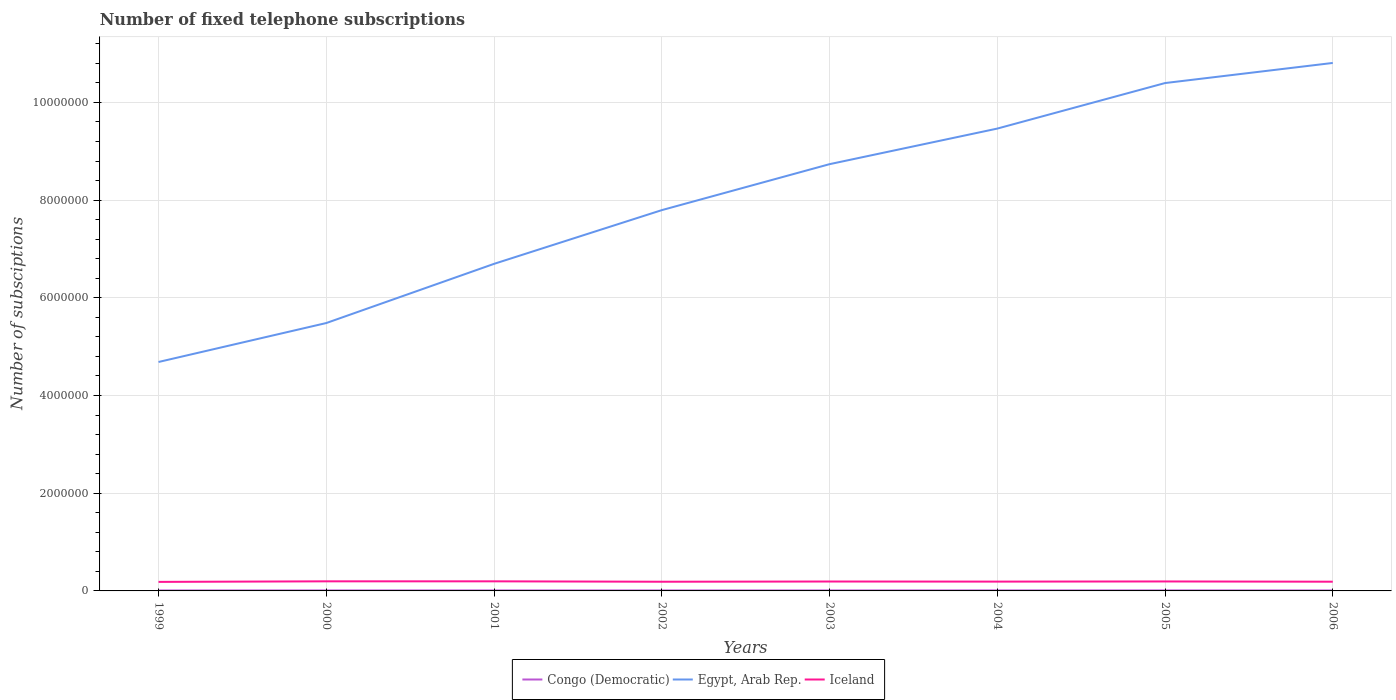How many different coloured lines are there?
Make the answer very short. 3. Does the line corresponding to Egypt, Arab Rep. intersect with the line corresponding to Iceland?
Offer a very short reply. No. Is the number of lines equal to the number of legend labels?
Make the answer very short. Yes. Across all years, what is the maximum number of fixed telephone subscriptions in Egypt, Arab Rep.?
Keep it short and to the point. 4.69e+06. In which year was the number of fixed telephone subscriptions in Egypt, Arab Rep. maximum?
Offer a terse response. 1999. What is the total number of fixed telephone subscriptions in Egypt, Arab Rep. in the graph?
Make the answer very short. -4.78e+06. What is the difference between the highest and the second highest number of fixed telephone subscriptions in Egypt, Arab Rep.?
Your response must be concise. 6.12e+06. What is the difference between the highest and the lowest number of fixed telephone subscriptions in Egypt, Arab Rep.?
Make the answer very short. 4. Is the number of fixed telephone subscriptions in Egypt, Arab Rep. strictly greater than the number of fixed telephone subscriptions in Iceland over the years?
Provide a succinct answer. No. How many lines are there?
Ensure brevity in your answer.  3. How many legend labels are there?
Keep it short and to the point. 3. How are the legend labels stacked?
Make the answer very short. Horizontal. What is the title of the graph?
Keep it short and to the point. Number of fixed telephone subscriptions. Does "Finland" appear as one of the legend labels in the graph?
Your answer should be compact. No. What is the label or title of the X-axis?
Provide a short and direct response. Years. What is the label or title of the Y-axis?
Keep it short and to the point. Number of subsciptions. What is the Number of subsciptions in Congo (Democratic) in 1999?
Your response must be concise. 9550. What is the Number of subsciptions of Egypt, Arab Rep. in 1999?
Offer a very short reply. 4.69e+06. What is the Number of subsciptions in Iceland in 1999?
Keep it short and to the point. 1.85e+05. What is the Number of subsciptions of Congo (Democratic) in 2000?
Your response must be concise. 9810. What is the Number of subsciptions in Egypt, Arab Rep. in 2000?
Ensure brevity in your answer.  5.48e+06. What is the Number of subsciptions in Iceland in 2000?
Make the answer very short. 1.96e+05. What is the Number of subsciptions of Congo (Democratic) in 2001?
Offer a very short reply. 9980. What is the Number of subsciptions of Egypt, Arab Rep. in 2001?
Your answer should be compact. 6.69e+06. What is the Number of subsciptions of Iceland in 2001?
Your response must be concise. 1.97e+05. What is the Number of subsciptions in Egypt, Arab Rep. in 2002?
Offer a very short reply. 7.79e+06. What is the Number of subsciptions of Iceland in 2002?
Ensure brevity in your answer.  1.88e+05. What is the Number of subsciptions in Congo (Democratic) in 2003?
Give a very brief answer. 9733. What is the Number of subsciptions of Egypt, Arab Rep. in 2003?
Give a very brief answer. 8.74e+06. What is the Number of subsciptions of Iceland in 2003?
Your answer should be compact. 1.93e+05. What is the Number of subsciptions of Congo (Democratic) in 2004?
Ensure brevity in your answer.  1.05e+04. What is the Number of subsciptions of Egypt, Arab Rep. in 2004?
Make the answer very short. 9.46e+06. What is the Number of subsciptions in Iceland in 2004?
Make the answer very short. 1.90e+05. What is the Number of subsciptions of Congo (Democratic) in 2005?
Give a very brief answer. 1.06e+04. What is the Number of subsciptions in Egypt, Arab Rep. in 2005?
Give a very brief answer. 1.04e+07. What is the Number of subsciptions in Iceland in 2005?
Make the answer very short. 1.94e+05. What is the Number of subsciptions of Congo (Democratic) in 2006?
Give a very brief answer. 9700. What is the Number of subsciptions of Egypt, Arab Rep. in 2006?
Keep it short and to the point. 1.08e+07. What is the Number of subsciptions in Iceland in 2006?
Your answer should be very brief. 1.89e+05. Across all years, what is the maximum Number of subsciptions of Congo (Democratic)?
Ensure brevity in your answer.  1.06e+04. Across all years, what is the maximum Number of subsciptions of Egypt, Arab Rep.?
Your answer should be compact. 1.08e+07. Across all years, what is the maximum Number of subsciptions of Iceland?
Provide a short and direct response. 1.97e+05. Across all years, what is the minimum Number of subsciptions in Congo (Democratic)?
Your response must be concise. 9550. Across all years, what is the minimum Number of subsciptions of Egypt, Arab Rep.?
Ensure brevity in your answer.  4.69e+06. Across all years, what is the minimum Number of subsciptions of Iceland?
Provide a succinct answer. 1.85e+05. What is the total Number of subsciptions of Congo (Democratic) in the graph?
Ensure brevity in your answer.  7.99e+04. What is the total Number of subsciptions of Egypt, Arab Rep. in the graph?
Your response must be concise. 6.41e+07. What is the total Number of subsciptions in Iceland in the graph?
Make the answer very short. 1.53e+06. What is the difference between the Number of subsciptions of Congo (Democratic) in 1999 and that in 2000?
Your answer should be very brief. -260. What is the difference between the Number of subsciptions of Egypt, Arab Rep. in 1999 and that in 2000?
Make the answer very short. -7.97e+05. What is the difference between the Number of subsciptions of Iceland in 1999 and that in 2000?
Keep it short and to the point. -1.14e+04. What is the difference between the Number of subsciptions in Congo (Democratic) in 1999 and that in 2001?
Make the answer very short. -430. What is the difference between the Number of subsciptions of Egypt, Arab Rep. in 1999 and that in 2001?
Ensure brevity in your answer.  -2.01e+06. What is the difference between the Number of subsciptions in Iceland in 1999 and that in 2001?
Keep it short and to the point. -1.16e+04. What is the difference between the Number of subsciptions in Congo (Democratic) in 1999 and that in 2002?
Make the answer very short. -450. What is the difference between the Number of subsciptions of Egypt, Arab Rep. in 1999 and that in 2002?
Offer a terse response. -3.11e+06. What is the difference between the Number of subsciptions of Iceland in 1999 and that in 2002?
Offer a terse response. -3026. What is the difference between the Number of subsciptions in Congo (Democratic) in 1999 and that in 2003?
Your response must be concise. -183. What is the difference between the Number of subsciptions in Egypt, Arab Rep. in 1999 and that in 2003?
Your answer should be very brief. -4.05e+06. What is the difference between the Number of subsciptions in Iceland in 1999 and that in 2003?
Your response must be concise. -7579. What is the difference between the Number of subsciptions in Congo (Democratic) in 1999 and that in 2004?
Your answer should be compact. -974. What is the difference between the Number of subsciptions of Egypt, Arab Rep. in 1999 and that in 2004?
Keep it short and to the point. -4.78e+06. What is the difference between the Number of subsciptions in Iceland in 1999 and that in 2004?
Your response must be concise. -5505. What is the difference between the Number of subsciptions of Congo (Democratic) in 1999 and that in 2005?
Provide a succinct answer. -1029. What is the difference between the Number of subsciptions in Egypt, Arab Rep. in 1999 and that in 2005?
Provide a succinct answer. -5.71e+06. What is the difference between the Number of subsciptions of Iceland in 1999 and that in 2005?
Your response must be concise. -8879. What is the difference between the Number of subsciptions in Congo (Democratic) in 1999 and that in 2006?
Ensure brevity in your answer.  -150. What is the difference between the Number of subsciptions of Egypt, Arab Rep. in 1999 and that in 2006?
Offer a terse response. -6.12e+06. What is the difference between the Number of subsciptions in Iceland in 1999 and that in 2006?
Offer a very short reply. -3602. What is the difference between the Number of subsciptions of Congo (Democratic) in 2000 and that in 2001?
Offer a terse response. -170. What is the difference between the Number of subsciptions in Egypt, Arab Rep. in 2000 and that in 2001?
Give a very brief answer. -1.21e+06. What is the difference between the Number of subsciptions of Iceland in 2000 and that in 2001?
Provide a succinct answer. -192. What is the difference between the Number of subsciptions in Congo (Democratic) in 2000 and that in 2002?
Provide a short and direct response. -190. What is the difference between the Number of subsciptions of Egypt, Arab Rep. in 2000 and that in 2002?
Keep it short and to the point. -2.31e+06. What is the difference between the Number of subsciptions of Iceland in 2000 and that in 2002?
Offer a very short reply. 8337. What is the difference between the Number of subsciptions in Congo (Democratic) in 2000 and that in 2003?
Your response must be concise. 77. What is the difference between the Number of subsciptions of Egypt, Arab Rep. in 2000 and that in 2003?
Provide a short and direct response. -3.25e+06. What is the difference between the Number of subsciptions of Iceland in 2000 and that in 2003?
Offer a very short reply. 3784. What is the difference between the Number of subsciptions of Congo (Democratic) in 2000 and that in 2004?
Your answer should be very brief. -714. What is the difference between the Number of subsciptions in Egypt, Arab Rep. in 2000 and that in 2004?
Give a very brief answer. -3.98e+06. What is the difference between the Number of subsciptions of Iceland in 2000 and that in 2004?
Your answer should be compact. 5858. What is the difference between the Number of subsciptions of Congo (Democratic) in 2000 and that in 2005?
Provide a succinct answer. -769. What is the difference between the Number of subsciptions of Egypt, Arab Rep. in 2000 and that in 2005?
Offer a terse response. -4.91e+06. What is the difference between the Number of subsciptions of Iceland in 2000 and that in 2005?
Keep it short and to the point. 2484. What is the difference between the Number of subsciptions in Congo (Democratic) in 2000 and that in 2006?
Offer a very short reply. 110. What is the difference between the Number of subsciptions in Egypt, Arab Rep. in 2000 and that in 2006?
Offer a very short reply. -5.32e+06. What is the difference between the Number of subsciptions in Iceland in 2000 and that in 2006?
Provide a succinct answer. 7761. What is the difference between the Number of subsciptions in Congo (Democratic) in 2001 and that in 2002?
Your answer should be very brief. -20. What is the difference between the Number of subsciptions of Egypt, Arab Rep. in 2001 and that in 2002?
Make the answer very short. -1.10e+06. What is the difference between the Number of subsciptions of Iceland in 2001 and that in 2002?
Your answer should be compact. 8529. What is the difference between the Number of subsciptions of Congo (Democratic) in 2001 and that in 2003?
Your answer should be compact. 247. What is the difference between the Number of subsciptions of Egypt, Arab Rep. in 2001 and that in 2003?
Your answer should be compact. -2.04e+06. What is the difference between the Number of subsciptions of Iceland in 2001 and that in 2003?
Offer a terse response. 3976. What is the difference between the Number of subsciptions of Congo (Democratic) in 2001 and that in 2004?
Provide a succinct answer. -544. What is the difference between the Number of subsciptions of Egypt, Arab Rep. in 2001 and that in 2004?
Give a very brief answer. -2.77e+06. What is the difference between the Number of subsciptions of Iceland in 2001 and that in 2004?
Provide a succinct answer. 6050. What is the difference between the Number of subsciptions in Congo (Democratic) in 2001 and that in 2005?
Your answer should be compact. -599. What is the difference between the Number of subsciptions in Egypt, Arab Rep. in 2001 and that in 2005?
Provide a succinct answer. -3.70e+06. What is the difference between the Number of subsciptions in Iceland in 2001 and that in 2005?
Your answer should be very brief. 2676. What is the difference between the Number of subsciptions in Congo (Democratic) in 2001 and that in 2006?
Keep it short and to the point. 280. What is the difference between the Number of subsciptions in Egypt, Arab Rep. in 2001 and that in 2006?
Your answer should be very brief. -4.11e+06. What is the difference between the Number of subsciptions in Iceland in 2001 and that in 2006?
Keep it short and to the point. 7953. What is the difference between the Number of subsciptions in Congo (Democratic) in 2002 and that in 2003?
Give a very brief answer. 267. What is the difference between the Number of subsciptions in Egypt, Arab Rep. in 2002 and that in 2003?
Make the answer very short. -9.41e+05. What is the difference between the Number of subsciptions of Iceland in 2002 and that in 2003?
Ensure brevity in your answer.  -4553. What is the difference between the Number of subsciptions in Congo (Democratic) in 2002 and that in 2004?
Provide a short and direct response. -524. What is the difference between the Number of subsciptions of Egypt, Arab Rep. in 2002 and that in 2004?
Offer a very short reply. -1.67e+06. What is the difference between the Number of subsciptions of Iceland in 2002 and that in 2004?
Provide a succinct answer. -2479. What is the difference between the Number of subsciptions of Congo (Democratic) in 2002 and that in 2005?
Your answer should be compact. -579. What is the difference between the Number of subsciptions in Egypt, Arab Rep. in 2002 and that in 2005?
Provide a succinct answer. -2.60e+06. What is the difference between the Number of subsciptions of Iceland in 2002 and that in 2005?
Your answer should be compact. -5853. What is the difference between the Number of subsciptions in Congo (Democratic) in 2002 and that in 2006?
Ensure brevity in your answer.  300. What is the difference between the Number of subsciptions of Egypt, Arab Rep. in 2002 and that in 2006?
Your response must be concise. -3.01e+06. What is the difference between the Number of subsciptions in Iceland in 2002 and that in 2006?
Make the answer very short. -576. What is the difference between the Number of subsciptions of Congo (Democratic) in 2003 and that in 2004?
Keep it short and to the point. -791. What is the difference between the Number of subsciptions of Egypt, Arab Rep. in 2003 and that in 2004?
Your answer should be very brief. -7.28e+05. What is the difference between the Number of subsciptions in Iceland in 2003 and that in 2004?
Your answer should be very brief. 2074. What is the difference between the Number of subsciptions of Congo (Democratic) in 2003 and that in 2005?
Offer a very short reply. -846. What is the difference between the Number of subsciptions of Egypt, Arab Rep. in 2003 and that in 2005?
Offer a very short reply. -1.66e+06. What is the difference between the Number of subsciptions of Iceland in 2003 and that in 2005?
Offer a very short reply. -1300. What is the difference between the Number of subsciptions of Egypt, Arab Rep. in 2003 and that in 2006?
Make the answer very short. -2.07e+06. What is the difference between the Number of subsciptions of Iceland in 2003 and that in 2006?
Offer a very short reply. 3977. What is the difference between the Number of subsciptions of Congo (Democratic) in 2004 and that in 2005?
Ensure brevity in your answer.  -55. What is the difference between the Number of subsciptions of Egypt, Arab Rep. in 2004 and that in 2005?
Your response must be concise. -9.32e+05. What is the difference between the Number of subsciptions of Iceland in 2004 and that in 2005?
Give a very brief answer. -3374. What is the difference between the Number of subsciptions in Congo (Democratic) in 2004 and that in 2006?
Offer a terse response. 824. What is the difference between the Number of subsciptions of Egypt, Arab Rep. in 2004 and that in 2006?
Offer a terse response. -1.34e+06. What is the difference between the Number of subsciptions in Iceland in 2004 and that in 2006?
Your response must be concise. 1903. What is the difference between the Number of subsciptions of Congo (Democratic) in 2005 and that in 2006?
Keep it short and to the point. 879. What is the difference between the Number of subsciptions in Egypt, Arab Rep. in 2005 and that in 2006?
Ensure brevity in your answer.  -4.12e+05. What is the difference between the Number of subsciptions of Iceland in 2005 and that in 2006?
Provide a succinct answer. 5277. What is the difference between the Number of subsciptions of Congo (Democratic) in 1999 and the Number of subsciptions of Egypt, Arab Rep. in 2000?
Offer a very short reply. -5.47e+06. What is the difference between the Number of subsciptions in Congo (Democratic) in 1999 and the Number of subsciptions in Iceland in 2000?
Make the answer very short. -1.87e+05. What is the difference between the Number of subsciptions in Egypt, Arab Rep. in 1999 and the Number of subsciptions in Iceland in 2000?
Ensure brevity in your answer.  4.49e+06. What is the difference between the Number of subsciptions of Congo (Democratic) in 1999 and the Number of subsciptions of Egypt, Arab Rep. in 2001?
Offer a terse response. -6.69e+06. What is the difference between the Number of subsciptions in Congo (Democratic) in 1999 and the Number of subsciptions in Iceland in 2001?
Offer a very short reply. -1.87e+05. What is the difference between the Number of subsciptions of Egypt, Arab Rep. in 1999 and the Number of subsciptions of Iceland in 2001?
Give a very brief answer. 4.49e+06. What is the difference between the Number of subsciptions in Congo (Democratic) in 1999 and the Number of subsciptions in Egypt, Arab Rep. in 2002?
Keep it short and to the point. -7.79e+06. What is the difference between the Number of subsciptions of Congo (Democratic) in 1999 and the Number of subsciptions of Iceland in 2002?
Your response must be concise. -1.78e+05. What is the difference between the Number of subsciptions of Egypt, Arab Rep. in 1999 and the Number of subsciptions of Iceland in 2002?
Provide a short and direct response. 4.50e+06. What is the difference between the Number of subsciptions of Congo (Democratic) in 1999 and the Number of subsciptions of Egypt, Arab Rep. in 2003?
Offer a terse response. -8.73e+06. What is the difference between the Number of subsciptions in Congo (Democratic) in 1999 and the Number of subsciptions in Iceland in 2003?
Make the answer very short. -1.83e+05. What is the difference between the Number of subsciptions in Egypt, Arab Rep. in 1999 and the Number of subsciptions in Iceland in 2003?
Provide a succinct answer. 4.49e+06. What is the difference between the Number of subsciptions in Congo (Democratic) in 1999 and the Number of subsciptions in Egypt, Arab Rep. in 2004?
Your response must be concise. -9.45e+06. What is the difference between the Number of subsciptions in Congo (Democratic) in 1999 and the Number of subsciptions in Iceland in 2004?
Give a very brief answer. -1.81e+05. What is the difference between the Number of subsciptions of Egypt, Arab Rep. in 1999 and the Number of subsciptions of Iceland in 2004?
Your answer should be compact. 4.50e+06. What is the difference between the Number of subsciptions of Congo (Democratic) in 1999 and the Number of subsciptions of Egypt, Arab Rep. in 2005?
Give a very brief answer. -1.04e+07. What is the difference between the Number of subsciptions in Congo (Democratic) in 1999 and the Number of subsciptions in Iceland in 2005?
Offer a very short reply. -1.84e+05. What is the difference between the Number of subsciptions in Egypt, Arab Rep. in 1999 and the Number of subsciptions in Iceland in 2005?
Make the answer very short. 4.49e+06. What is the difference between the Number of subsciptions in Congo (Democratic) in 1999 and the Number of subsciptions in Egypt, Arab Rep. in 2006?
Keep it short and to the point. -1.08e+07. What is the difference between the Number of subsciptions of Congo (Democratic) in 1999 and the Number of subsciptions of Iceland in 2006?
Provide a succinct answer. -1.79e+05. What is the difference between the Number of subsciptions of Egypt, Arab Rep. in 1999 and the Number of subsciptions of Iceland in 2006?
Provide a succinct answer. 4.50e+06. What is the difference between the Number of subsciptions in Congo (Democratic) in 2000 and the Number of subsciptions in Egypt, Arab Rep. in 2001?
Offer a very short reply. -6.69e+06. What is the difference between the Number of subsciptions in Congo (Democratic) in 2000 and the Number of subsciptions in Iceland in 2001?
Provide a succinct answer. -1.87e+05. What is the difference between the Number of subsciptions of Egypt, Arab Rep. in 2000 and the Number of subsciptions of Iceland in 2001?
Keep it short and to the point. 5.29e+06. What is the difference between the Number of subsciptions of Congo (Democratic) in 2000 and the Number of subsciptions of Egypt, Arab Rep. in 2002?
Offer a terse response. -7.78e+06. What is the difference between the Number of subsciptions in Congo (Democratic) in 2000 and the Number of subsciptions in Iceland in 2002?
Provide a succinct answer. -1.78e+05. What is the difference between the Number of subsciptions of Egypt, Arab Rep. in 2000 and the Number of subsciptions of Iceland in 2002?
Give a very brief answer. 5.30e+06. What is the difference between the Number of subsciptions of Congo (Democratic) in 2000 and the Number of subsciptions of Egypt, Arab Rep. in 2003?
Ensure brevity in your answer.  -8.73e+06. What is the difference between the Number of subsciptions in Congo (Democratic) in 2000 and the Number of subsciptions in Iceland in 2003?
Ensure brevity in your answer.  -1.83e+05. What is the difference between the Number of subsciptions in Egypt, Arab Rep. in 2000 and the Number of subsciptions in Iceland in 2003?
Your answer should be compact. 5.29e+06. What is the difference between the Number of subsciptions in Congo (Democratic) in 2000 and the Number of subsciptions in Egypt, Arab Rep. in 2004?
Your answer should be very brief. -9.45e+06. What is the difference between the Number of subsciptions in Congo (Democratic) in 2000 and the Number of subsciptions in Iceland in 2004?
Provide a short and direct response. -1.81e+05. What is the difference between the Number of subsciptions in Egypt, Arab Rep. in 2000 and the Number of subsciptions in Iceland in 2004?
Give a very brief answer. 5.29e+06. What is the difference between the Number of subsciptions in Congo (Democratic) in 2000 and the Number of subsciptions in Egypt, Arab Rep. in 2005?
Make the answer very short. -1.04e+07. What is the difference between the Number of subsciptions of Congo (Democratic) in 2000 and the Number of subsciptions of Iceland in 2005?
Your answer should be compact. -1.84e+05. What is the difference between the Number of subsciptions of Egypt, Arab Rep. in 2000 and the Number of subsciptions of Iceland in 2005?
Make the answer very short. 5.29e+06. What is the difference between the Number of subsciptions of Congo (Democratic) in 2000 and the Number of subsciptions of Egypt, Arab Rep. in 2006?
Offer a very short reply. -1.08e+07. What is the difference between the Number of subsciptions of Congo (Democratic) in 2000 and the Number of subsciptions of Iceland in 2006?
Offer a terse response. -1.79e+05. What is the difference between the Number of subsciptions of Egypt, Arab Rep. in 2000 and the Number of subsciptions of Iceland in 2006?
Give a very brief answer. 5.30e+06. What is the difference between the Number of subsciptions in Congo (Democratic) in 2001 and the Number of subsciptions in Egypt, Arab Rep. in 2002?
Offer a terse response. -7.78e+06. What is the difference between the Number of subsciptions in Congo (Democratic) in 2001 and the Number of subsciptions in Iceland in 2002?
Give a very brief answer. -1.78e+05. What is the difference between the Number of subsciptions in Egypt, Arab Rep. in 2001 and the Number of subsciptions in Iceland in 2002?
Ensure brevity in your answer.  6.51e+06. What is the difference between the Number of subsciptions of Congo (Democratic) in 2001 and the Number of subsciptions of Egypt, Arab Rep. in 2003?
Your response must be concise. -8.73e+06. What is the difference between the Number of subsciptions in Congo (Democratic) in 2001 and the Number of subsciptions in Iceland in 2003?
Your answer should be compact. -1.83e+05. What is the difference between the Number of subsciptions in Egypt, Arab Rep. in 2001 and the Number of subsciptions in Iceland in 2003?
Offer a very short reply. 6.50e+06. What is the difference between the Number of subsciptions of Congo (Democratic) in 2001 and the Number of subsciptions of Egypt, Arab Rep. in 2004?
Your answer should be very brief. -9.45e+06. What is the difference between the Number of subsciptions in Congo (Democratic) in 2001 and the Number of subsciptions in Iceland in 2004?
Your answer should be compact. -1.80e+05. What is the difference between the Number of subsciptions of Egypt, Arab Rep. in 2001 and the Number of subsciptions of Iceland in 2004?
Keep it short and to the point. 6.50e+06. What is the difference between the Number of subsciptions of Congo (Democratic) in 2001 and the Number of subsciptions of Egypt, Arab Rep. in 2005?
Keep it short and to the point. -1.04e+07. What is the difference between the Number of subsciptions in Congo (Democratic) in 2001 and the Number of subsciptions in Iceland in 2005?
Provide a succinct answer. -1.84e+05. What is the difference between the Number of subsciptions in Egypt, Arab Rep. in 2001 and the Number of subsciptions in Iceland in 2005?
Your answer should be compact. 6.50e+06. What is the difference between the Number of subsciptions of Congo (Democratic) in 2001 and the Number of subsciptions of Egypt, Arab Rep. in 2006?
Offer a terse response. -1.08e+07. What is the difference between the Number of subsciptions in Congo (Democratic) in 2001 and the Number of subsciptions in Iceland in 2006?
Provide a succinct answer. -1.79e+05. What is the difference between the Number of subsciptions in Egypt, Arab Rep. in 2001 and the Number of subsciptions in Iceland in 2006?
Provide a succinct answer. 6.51e+06. What is the difference between the Number of subsciptions of Congo (Democratic) in 2002 and the Number of subsciptions of Egypt, Arab Rep. in 2003?
Offer a very short reply. -8.73e+06. What is the difference between the Number of subsciptions in Congo (Democratic) in 2002 and the Number of subsciptions in Iceland in 2003?
Your response must be concise. -1.83e+05. What is the difference between the Number of subsciptions in Egypt, Arab Rep. in 2002 and the Number of subsciptions in Iceland in 2003?
Your answer should be compact. 7.60e+06. What is the difference between the Number of subsciptions of Congo (Democratic) in 2002 and the Number of subsciptions of Egypt, Arab Rep. in 2004?
Provide a succinct answer. -9.45e+06. What is the difference between the Number of subsciptions in Congo (Democratic) in 2002 and the Number of subsciptions in Iceland in 2004?
Your answer should be very brief. -1.80e+05. What is the difference between the Number of subsciptions in Egypt, Arab Rep. in 2002 and the Number of subsciptions in Iceland in 2004?
Your answer should be very brief. 7.60e+06. What is the difference between the Number of subsciptions of Congo (Democratic) in 2002 and the Number of subsciptions of Egypt, Arab Rep. in 2005?
Keep it short and to the point. -1.04e+07. What is the difference between the Number of subsciptions in Congo (Democratic) in 2002 and the Number of subsciptions in Iceland in 2005?
Offer a very short reply. -1.84e+05. What is the difference between the Number of subsciptions of Egypt, Arab Rep. in 2002 and the Number of subsciptions of Iceland in 2005?
Offer a very short reply. 7.60e+06. What is the difference between the Number of subsciptions of Congo (Democratic) in 2002 and the Number of subsciptions of Egypt, Arab Rep. in 2006?
Offer a very short reply. -1.08e+07. What is the difference between the Number of subsciptions of Congo (Democratic) in 2002 and the Number of subsciptions of Iceland in 2006?
Ensure brevity in your answer.  -1.79e+05. What is the difference between the Number of subsciptions in Egypt, Arab Rep. in 2002 and the Number of subsciptions in Iceland in 2006?
Ensure brevity in your answer.  7.61e+06. What is the difference between the Number of subsciptions of Congo (Democratic) in 2003 and the Number of subsciptions of Egypt, Arab Rep. in 2004?
Make the answer very short. -9.45e+06. What is the difference between the Number of subsciptions in Congo (Democratic) in 2003 and the Number of subsciptions in Iceland in 2004?
Give a very brief answer. -1.81e+05. What is the difference between the Number of subsciptions in Egypt, Arab Rep. in 2003 and the Number of subsciptions in Iceland in 2004?
Provide a succinct answer. 8.55e+06. What is the difference between the Number of subsciptions in Congo (Democratic) in 2003 and the Number of subsciptions in Egypt, Arab Rep. in 2005?
Keep it short and to the point. -1.04e+07. What is the difference between the Number of subsciptions in Congo (Democratic) in 2003 and the Number of subsciptions in Iceland in 2005?
Provide a short and direct response. -1.84e+05. What is the difference between the Number of subsciptions in Egypt, Arab Rep. in 2003 and the Number of subsciptions in Iceland in 2005?
Give a very brief answer. 8.54e+06. What is the difference between the Number of subsciptions of Congo (Democratic) in 2003 and the Number of subsciptions of Egypt, Arab Rep. in 2006?
Offer a terse response. -1.08e+07. What is the difference between the Number of subsciptions in Congo (Democratic) in 2003 and the Number of subsciptions in Iceland in 2006?
Give a very brief answer. -1.79e+05. What is the difference between the Number of subsciptions of Egypt, Arab Rep. in 2003 and the Number of subsciptions of Iceland in 2006?
Provide a succinct answer. 8.55e+06. What is the difference between the Number of subsciptions of Congo (Democratic) in 2004 and the Number of subsciptions of Egypt, Arab Rep. in 2005?
Your answer should be very brief. -1.04e+07. What is the difference between the Number of subsciptions in Congo (Democratic) in 2004 and the Number of subsciptions in Iceland in 2005?
Offer a terse response. -1.83e+05. What is the difference between the Number of subsciptions in Egypt, Arab Rep. in 2004 and the Number of subsciptions in Iceland in 2005?
Ensure brevity in your answer.  9.27e+06. What is the difference between the Number of subsciptions of Congo (Democratic) in 2004 and the Number of subsciptions of Egypt, Arab Rep. in 2006?
Provide a short and direct response. -1.08e+07. What is the difference between the Number of subsciptions of Congo (Democratic) in 2004 and the Number of subsciptions of Iceland in 2006?
Provide a short and direct response. -1.78e+05. What is the difference between the Number of subsciptions of Egypt, Arab Rep. in 2004 and the Number of subsciptions of Iceland in 2006?
Your response must be concise. 9.28e+06. What is the difference between the Number of subsciptions in Congo (Democratic) in 2005 and the Number of subsciptions in Egypt, Arab Rep. in 2006?
Offer a terse response. -1.08e+07. What is the difference between the Number of subsciptions of Congo (Democratic) in 2005 and the Number of subsciptions of Iceland in 2006?
Provide a succinct answer. -1.78e+05. What is the difference between the Number of subsciptions in Egypt, Arab Rep. in 2005 and the Number of subsciptions in Iceland in 2006?
Your answer should be compact. 1.02e+07. What is the average Number of subsciptions of Congo (Democratic) per year?
Make the answer very short. 9984.5. What is the average Number of subsciptions in Egypt, Arab Rep. per year?
Make the answer very short. 8.01e+06. What is the average Number of subsciptions in Iceland per year?
Ensure brevity in your answer.  1.91e+05. In the year 1999, what is the difference between the Number of subsciptions in Congo (Democratic) and Number of subsciptions in Egypt, Arab Rep.?
Offer a terse response. -4.68e+06. In the year 1999, what is the difference between the Number of subsciptions in Congo (Democratic) and Number of subsciptions in Iceland?
Provide a succinct answer. -1.75e+05. In the year 1999, what is the difference between the Number of subsciptions of Egypt, Arab Rep. and Number of subsciptions of Iceland?
Your answer should be compact. 4.50e+06. In the year 2000, what is the difference between the Number of subsciptions in Congo (Democratic) and Number of subsciptions in Egypt, Arab Rep.?
Your answer should be compact. -5.47e+06. In the year 2000, what is the difference between the Number of subsciptions in Congo (Democratic) and Number of subsciptions in Iceland?
Ensure brevity in your answer.  -1.87e+05. In the year 2000, what is the difference between the Number of subsciptions in Egypt, Arab Rep. and Number of subsciptions in Iceland?
Your answer should be compact. 5.29e+06. In the year 2001, what is the difference between the Number of subsciptions in Congo (Democratic) and Number of subsciptions in Egypt, Arab Rep.?
Give a very brief answer. -6.68e+06. In the year 2001, what is the difference between the Number of subsciptions of Congo (Democratic) and Number of subsciptions of Iceland?
Keep it short and to the point. -1.87e+05. In the year 2001, what is the difference between the Number of subsciptions in Egypt, Arab Rep. and Number of subsciptions in Iceland?
Make the answer very short. 6.50e+06. In the year 2002, what is the difference between the Number of subsciptions of Congo (Democratic) and Number of subsciptions of Egypt, Arab Rep.?
Your answer should be very brief. -7.78e+06. In the year 2002, what is the difference between the Number of subsciptions of Congo (Democratic) and Number of subsciptions of Iceland?
Give a very brief answer. -1.78e+05. In the year 2002, what is the difference between the Number of subsciptions in Egypt, Arab Rep. and Number of subsciptions in Iceland?
Keep it short and to the point. 7.61e+06. In the year 2003, what is the difference between the Number of subsciptions of Congo (Democratic) and Number of subsciptions of Egypt, Arab Rep.?
Ensure brevity in your answer.  -8.73e+06. In the year 2003, what is the difference between the Number of subsciptions in Congo (Democratic) and Number of subsciptions in Iceland?
Keep it short and to the point. -1.83e+05. In the year 2003, what is the difference between the Number of subsciptions in Egypt, Arab Rep. and Number of subsciptions in Iceland?
Provide a short and direct response. 8.54e+06. In the year 2004, what is the difference between the Number of subsciptions in Congo (Democratic) and Number of subsciptions in Egypt, Arab Rep.?
Your answer should be very brief. -9.45e+06. In the year 2004, what is the difference between the Number of subsciptions of Congo (Democratic) and Number of subsciptions of Iceland?
Provide a succinct answer. -1.80e+05. In the year 2004, what is the difference between the Number of subsciptions in Egypt, Arab Rep. and Number of subsciptions in Iceland?
Your answer should be very brief. 9.27e+06. In the year 2005, what is the difference between the Number of subsciptions in Congo (Democratic) and Number of subsciptions in Egypt, Arab Rep.?
Ensure brevity in your answer.  -1.04e+07. In the year 2005, what is the difference between the Number of subsciptions in Congo (Democratic) and Number of subsciptions in Iceland?
Give a very brief answer. -1.83e+05. In the year 2005, what is the difference between the Number of subsciptions of Egypt, Arab Rep. and Number of subsciptions of Iceland?
Your answer should be compact. 1.02e+07. In the year 2006, what is the difference between the Number of subsciptions in Congo (Democratic) and Number of subsciptions in Egypt, Arab Rep.?
Provide a short and direct response. -1.08e+07. In the year 2006, what is the difference between the Number of subsciptions of Congo (Democratic) and Number of subsciptions of Iceland?
Offer a terse response. -1.79e+05. In the year 2006, what is the difference between the Number of subsciptions of Egypt, Arab Rep. and Number of subsciptions of Iceland?
Ensure brevity in your answer.  1.06e+07. What is the ratio of the Number of subsciptions in Congo (Democratic) in 1999 to that in 2000?
Offer a terse response. 0.97. What is the ratio of the Number of subsciptions of Egypt, Arab Rep. in 1999 to that in 2000?
Your answer should be compact. 0.85. What is the ratio of the Number of subsciptions of Iceland in 1999 to that in 2000?
Give a very brief answer. 0.94. What is the ratio of the Number of subsciptions in Congo (Democratic) in 1999 to that in 2001?
Your answer should be compact. 0.96. What is the ratio of the Number of subsciptions of Congo (Democratic) in 1999 to that in 2002?
Keep it short and to the point. 0.95. What is the ratio of the Number of subsciptions in Egypt, Arab Rep. in 1999 to that in 2002?
Make the answer very short. 0.6. What is the ratio of the Number of subsciptions of Iceland in 1999 to that in 2002?
Your answer should be compact. 0.98. What is the ratio of the Number of subsciptions of Congo (Democratic) in 1999 to that in 2003?
Offer a very short reply. 0.98. What is the ratio of the Number of subsciptions of Egypt, Arab Rep. in 1999 to that in 2003?
Provide a succinct answer. 0.54. What is the ratio of the Number of subsciptions in Iceland in 1999 to that in 2003?
Keep it short and to the point. 0.96. What is the ratio of the Number of subsciptions of Congo (Democratic) in 1999 to that in 2004?
Your response must be concise. 0.91. What is the ratio of the Number of subsciptions of Egypt, Arab Rep. in 1999 to that in 2004?
Make the answer very short. 0.5. What is the ratio of the Number of subsciptions of Iceland in 1999 to that in 2004?
Your response must be concise. 0.97. What is the ratio of the Number of subsciptions of Congo (Democratic) in 1999 to that in 2005?
Make the answer very short. 0.9. What is the ratio of the Number of subsciptions in Egypt, Arab Rep. in 1999 to that in 2005?
Your answer should be very brief. 0.45. What is the ratio of the Number of subsciptions in Iceland in 1999 to that in 2005?
Offer a terse response. 0.95. What is the ratio of the Number of subsciptions of Congo (Democratic) in 1999 to that in 2006?
Make the answer very short. 0.98. What is the ratio of the Number of subsciptions of Egypt, Arab Rep. in 1999 to that in 2006?
Keep it short and to the point. 0.43. What is the ratio of the Number of subsciptions of Iceland in 1999 to that in 2006?
Your response must be concise. 0.98. What is the ratio of the Number of subsciptions in Egypt, Arab Rep. in 2000 to that in 2001?
Ensure brevity in your answer.  0.82. What is the ratio of the Number of subsciptions in Congo (Democratic) in 2000 to that in 2002?
Give a very brief answer. 0.98. What is the ratio of the Number of subsciptions in Egypt, Arab Rep. in 2000 to that in 2002?
Ensure brevity in your answer.  0.7. What is the ratio of the Number of subsciptions in Iceland in 2000 to that in 2002?
Your answer should be very brief. 1.04. What is the ratio of the Number of subsciptions in Congo (Democratic) in 2000 to that in 2003?
Your answer should be very brief. 1.01. What is the ratio of the Number of subsciptions in Egypt, Arab Rep. in 2000 to that in 2003?
Provide a short and direct response. 0.63. What is the ratio of the Number of subsciptions of Iceland in 2000 to that in 2003?
Offer a terse response. 1.02. What is the ratio of the Number of subsciptions of Congo (Democratic) in 2000 to that in 2004?
Keep it short and to the point. 0.93. What is the ratio of the Number of subsciptions in Egypt, Arab Rep. in 2000 to that in 2004?
Your answer should be compact. 0.58. What is the ratio of the Number of subsciptions of Iceland in 2000 to that in 2004?
Provide a short and direct response. 1.03. What is the ratio of the Number of subsciptions in Congo (Democratic) in 2000 to that in 2005?
Provide a short and direct response. 0.93. What is the ratio of the Number of subsciptions of Egypt, Arab Rep. in 2000 to that in 2005?
Make the answer very short. 0.53. What is the ratio of the Number of subsciptions in Iceland in 2000 to that in 2005?
Offer a very short reply. 1.01. What is the ratio of the Number of subsciptions in Congo (Democratic) in 2000 to that in 2006?
Keep it short and to the point. 1.01. What is the ratio of the Number of subsciptions in Egypt, Arab Rep. in 2000 to that in 2006?
Keep it short and to the point. 0.51. What is the ratio of the Number of subsciptions in Iceland in 2000 to that in 2006?
Provide a succinct answer. 1.04. What is the ratio of the Number of subsciptions of Congo (Democratic) in 2001 to that in 2002?
Your answer should be compact. 1. What is the ratio of the Number of subsciptions of Egypt, Arab Rep. in 2001 to that in 2002?
Provide a short and direct response. 0.86. What is the ratio of the Number of subsciptions in Iceland in 2001 to that in 2002?
Your answer should be compact. 1.05. What is the ratio of the Number of subsciptions in Congo (Democratic) in 2001 to that in 2003?
Give a very brief answer. 1.03. What is the ratio of the Number of subsciptions of Egypt, Arab Rep. in 2001 to that in 2003?
Offer a very short reply. 0.77. What is the ratio of the Number of subsciptions of Iceland in 2001 to that in 2003?
Provide a succinct answer. 1.02. What is the ratio of the Number of subsciptions in Congo (Democratic) in 2001 to that in 2004?
Your answer should be very brief. 0.95. What is the ratio of the Number of subsciptions in Egypt, Arab Rep. in 2001 to that in 2004?
Your response must be concise. 0.71. What is the ratio of the Number of subsciptions of Iceland in 2001 to that in 2004?
Offer a terse response. 1.03. What is the ratio of the Number of subsciptions in Congo (Democratic) in 2001 to that in 2005?
Give a very brief answer. 0.94. What is the ratio of the Number of subsciptions in Egypt, Arab Rep. in 2001 to that in 2005?
Your response must be concise. 0.64. What is the ratio of the Number of subsciptions in Iceland in 2001 to that in 2005?
Give a very brief answer. 1.01. What is the ratio of the Number of subsciptions in Congo (Democratic) in 2001 to that in 2006?
Provide a succinct answer. 1.03. What is the ratio of the Number of subsciptions in Egypt, Arab Rep. in 2001 to that in 2006?
Make the answer very short. 0.62. What is the ratio of the Number of subsciptions in Iceland in 2001 to that in 2006?
Your answer should be compact. 1.04. What is the ratio of the Number of subsciptions of Congo (Democratic) in 2002 to that in 2003?
Provide a short and direct response. 1.03. What is the ratio of the Number of subsciptions of Egypt, Arab Rep. in 2002 to that in 2003?
Give a very brief answer. 0.89. What is the ratio of the Number of subsciptions in Iceland in 2002 to that in 2003?
Your answer should be very brief. 0.98. What is the ratio of the Number of subsciptions of Congo (Democratic) in 2002 to that in 2004?
Provide a succinct answer. 0.95. What is the ratio of the Number of subsciptions in Egypt, Arab Rep. in 2002 to that in 2004?
Offer a very short reply. 0.82. What is the ratio of the Number of subsciptions of Iceland in 2002 to that in 2004?
Offer a very short reply. 0.99. What is the ratio of the Number of subsciptions of Congo (Democratic) in 2002 to that in 2005?
Your answer should be compact. 0.95. What is the ratio of the Number of subsciptions of Egypt, Arab Rep. in 2002 to that in 2005?
Your response must be concise. 0.75. What is the ratio of the Number of subsciptions in Iceland in 2002 to that in 2005?
Your answer should be very brief. 0.97. What is the ratio of the Number of subsciptions in Congo (Democratic) in 2002 to that in 2006?
Make the answer very short. 1.03. What is the ratio of the Number of subsciptions in Egypt, Arab Rep. in 2002 to that in 2006?
Provide a succinct answer. 0.72. What is the ratio of the Number of subsciptions of Iceland in 2002 to that in 2006?
Offer a terse response. 1. What is the ratio of the Number of subsciptions in Congo (Democratic) in 2003 to that in 2004?
Offer a very short reply. 0.92. What is the ratio of the Number of subsciptions of Egypt, Arab Rep. in 2003 to that in 2004?
Provide a short and direct response. 0.92. What is the ratio of the Number of subsciptions in Iceland in 2003 to that in 2004?
Give a very brief answer. 1.01. What is the ratio of the Number of subsciptions in Congo (Democratic) in 2003 to that in 2005?
Your answer should be compact. 0.92. What is the ratio of the Number of subsciptions in Egypt, Arab Rep. in 2003 to that in 2005?
Your answer should be very brief. 0.84. What is the ratio of the Number of subsciptions in Iceland in 2003 to that in 2005?
Provide a short and direct response. 0.99. What is the ratio of the Number of subsciptions in Congo (Democratic) in 2003 to that in 2006?
Your answer should be very brief. 1. What is the ratio of the Number of subsciptions in Egypt, Arab Rep. in 2003 to that in 2006?
Your response must be concise. 0.81. What is the ratio of the Number of subsciptions in Iceland in 2003 to that in 2006?
Your answer should be compact. 1.02. What is the ratio of the Number of subsciptions of Congo (Democratic) in 2004 to that in 2005?
Keep it short and to the point. 0.99. What is the ratio of the Number of subsciptions in Egypt, Arab Rep. in 2004 to that in 2005?
Provide a succinct answer. 0.91. What is the ratio of the Number of subsciptions of Iceland in 2004 to that in 2005?
Offer a terse response. 0.98. What is the ratio of the Number of subsciptions of Congo (Democratic) in 2004 to that in 2006?
Your answer should be compact. 1.08. What is the ratio of the Number of subsciptions of Egypt, Arab Rep. in 2004 to that in 2006?
Provide a succinct answer. 0.88. What is the ratio of the Number of subsciptions of Congo (Democratic) in 2005 to that in 2006?
Keep it short and to the point. 1.09. What is the ratio of the Number of subsciptions in Egypt, Arab Rep. in 2005 to that in 2006?
Offer a very short reply. 0.96. What is the ratio of the Number of subsciptions in Iceland in 2005 to that in 2006?
Your answer should be compact. 1.03. What is the difference between the highest and the second highest Number of subsciptions of Egypt, Arab Rep.?
Make the answer very short. 4.12e+05. What is the difference between the highest and the second highest Number of subsciptions in Iceland?
Provide a succinct answer. 192. What is the difference between the highest and the lowest Number of subsciptions in Congo (Democratic)?
Offer a very short reply. 1029. What is the difference between the highest and the lowest Number of subsciptions of Egypt, Arab Rep.?
Give a very brief answer. 6.12e+06. What is the difference between the highest and the lowest Number of subsciptions of Iceland?
Your response must be concise. 1.16e+04. 